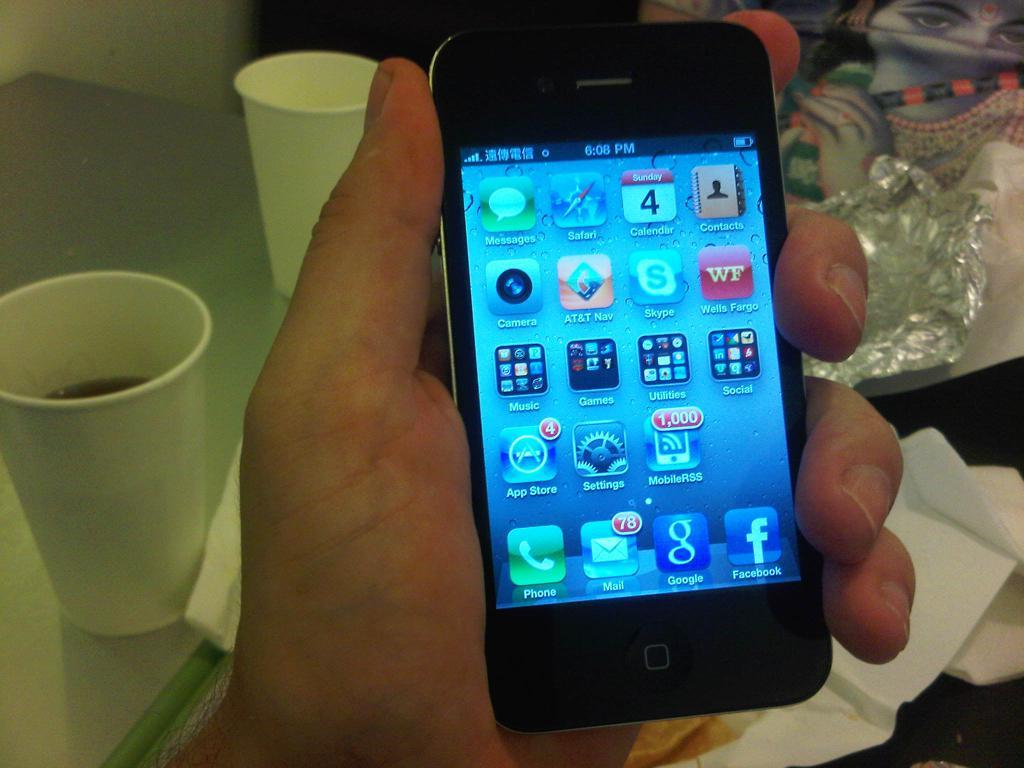<image>
Share a concise interpretation of the image provided. A smart phone in a hand, the word music is visible on one of the icons. 